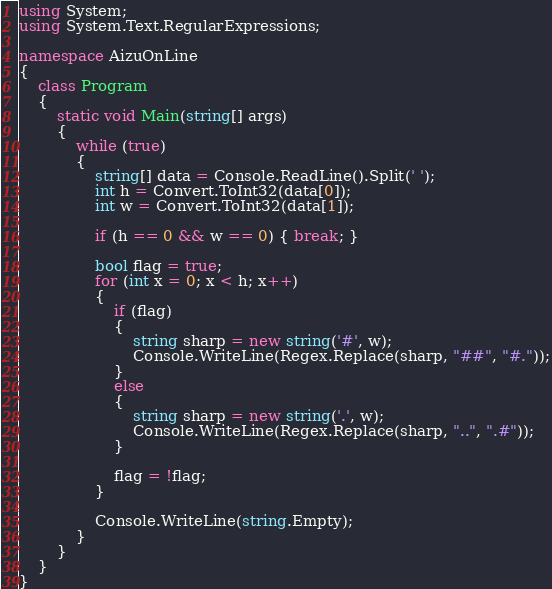Convert code to text. <code><loc_0><loc_0><loc_500><loc_500><_C#_>using System;
using System.Text.RegularExpressions;

namespace AizuOnLine
{
    class Program
    {
        static void Main(string[] args)
        {
            while (true)
            {
                string[] data = Console.ReadLine().Split(' ');
                int h = Convert.ToInt32(data[0]);
                int w = Convert.ToInt32(data[1]);

                if (h == 0 && w == 0) { break; }

                bool flag = true;
                for (int x = 0; x < h; x++)
                {
                    if (flag)
                    {
                        string sharp = new string('#', w);
                        Console.WriteLine(Regex.Replace(sharp, "##", "#."));
                    }
                    else
                    {
                        string sharp = new string('.', w);
                        Console.WriteLine(Regex.Replace(sharp, "..", ".#"));
                    }

                    flag = !flag;
                }

                Console.WriteLine(string.Empty);
            }
        }
    }
}</code> 